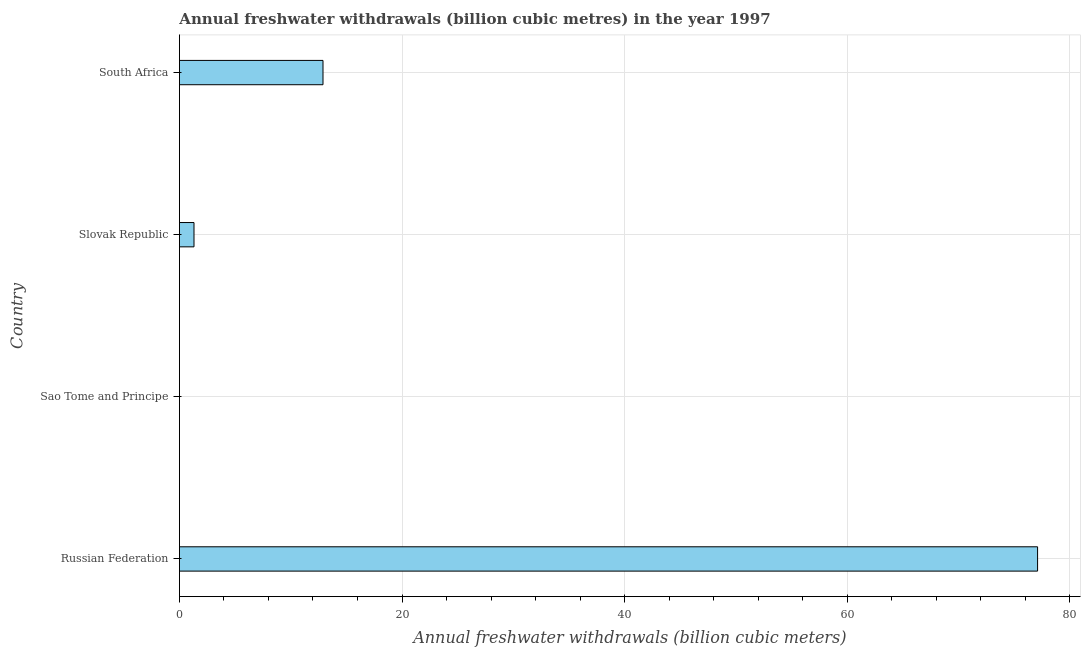Does the graph contain any zero values?
Keep it short and to the point. No. Does the graph contain grids?
Your answer should be compact. Yes. What is the title of the graph?
Your response must be concise. Annual freshwater withdrawals (billion cubic metres) in the year 1997. What is the label or title of the X-axis?
Your answer should be compact. Annual freshwater withdrawals (billion cubic meters). What is the annual freshwater withdrawals in Russian Federation?
Ensure brevity in your answer.  77.1. Across all countries, what is the maximum annual freshwater withdrawals?
Your answer should be compact. 77.1. Across all countries, what is the minimum annual freshwater withdrawals?
Provide a short and direct response. 0.01. In which country was the annual freshwater withdrawals maximum?
Ensure brevity in your answer.  Russian Federation. In which country was the annual freshwater withdrawals minimum?
Make the answer very short. Sao Tome and Principe. What is the sum of the annual freshwater withdrawals?
Keep it short and to the point. 91.32. What is the difference between the annual freshwater withdrawals in Slovak Republic and South Africa?
Offer a very short reply. -11.59. What is the average annual freshwater withdrawals per country?
Your answer should be very brief. 22.83. What is the median annual freshwater withdrawals?
Keep it short and to the point. 7.11. In how many countries, is the annual freshwater withdrawals greater than 40 billion cubic meters?
Your answer should be very brief. 1. What is the ratio of the annual freshwater withdrawals in Sao Tome and Principe to that in South Africa?
Offer a very short reply. 0. What is the difference between the highest and the second highest annual freshwater withdrawals?
Make the answer very short. 64.2. What is the difference between the highest and the lowest annual freshwater withdrawals?
Ensure brevity in your answer.  77.09. In how many countries, is the annual freshwater withdrawals greater than the average annual freshwater withdrawals taken over all countries?
Your answer should be compact. 1. Are all the bars in the graph horizontal?
Offer a terse response. Yes. Are the values on the major ticks of X-axis written in scientific E-notation?
Give a very brief answer. No. What is the Annual freshwater withdrawals (billion cubic meters) of Russian Federation?
Offer a terse response. 77.1. What is the Annual freshwater withdrawals (billion cubic meters) in Sao Tome and Principe?
Give a very brief answer. 0.01. What is the Annual freshwater withdrawals (billion cubic meters) in Slovak Republic?
Give a very brief answer. 1.31. What is the Annual freshwater withdrawals (billion cubic meters) of South Africa?
Provide a succinct answer. 12.9. What is the difference between the Annual freshwater withdrawals (billion cubic meters) in Russian Federation and Sao Tome and Principe?
Your answer should be compact. 77.09. What is the difference between the Annual freshwater withdrawals (billion cubic meters) in Russian Federation and Slovak Republic?
Ensure brevity in your answer.  75.79. What is the difference between the Annual freshwater withdrawals (billion cubic meters) in Russian Federation and South Africa?
Provide a succinct answer. 64.2. What is the difference between the Annual freshwater withdrawals (billion cubic meters) in Sao Tome and Principe and Slovak Republic?
Your answer should be very brief. -1.3. What is the difference between the Annual freshwater withdrawals (billion cubic meters) in Sao Tome and Principe and South Africa?
Provide a short and direct response. -12.89. What is the difference between the Annual freshwater withdrawals (billion cubic meters) in Slovak Republic and South Africa?
Ensure brevity in your answer.  -11.59. What is the ratio of the Annual freshwater withdrawals (billion cubic meters) in Russian Federation to that in Sao Tome and Principe?
Provide a short and direct response. 1.10e+04. What is the ratio of the Annual freshwater withdrawals (billion cubic meters) in Russian Federation to that in Slovak Republic?
Make the answer very short. 58.85. What is the ratio of the Annual freshwater withdrawals (billion cubic meters) in Russian Federation to that in South Africa?
Your answer should be compact. 5.98. What is the ratio of the Annual freshwater withdrawals (billion cubic meters) in Sao Tome and Principe to that in Slovak Republic?
Ensure brevity in your answer.  0.01. What is the ratio of the Annual freshwater withdrawals (billion cubic meters) in Slovak Republic to that in South Africa?
Your response must be concise. 0.1. 